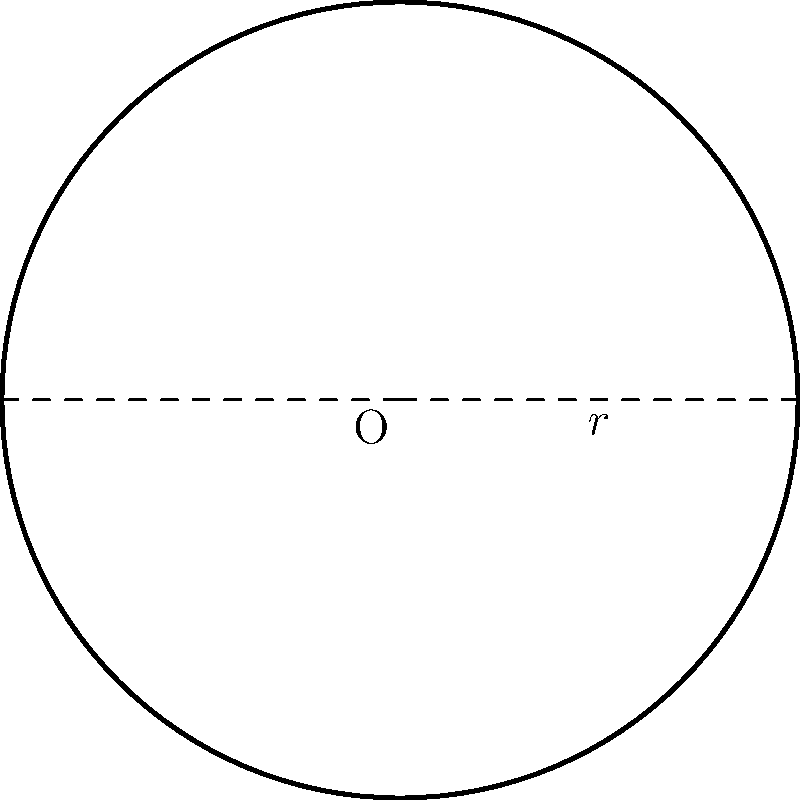A new high-performance motorcycle brake disc is being designed with a radius of 15 cm. What is the total surface area of the brake disc, rounded to the nearest square centimeter? To find the area of the circular brake disc, we can use the formula for the area of a circle:

$$A = \pi r^2$$

Where:
$A$ is the area of the circle
$\pi$ is approximately 3.14159
$r$ is the radius of the circle

Given:
$r = 15$ cm

Step 1: Substitute the value of $r$ into the formula:
$$A = \pi (15\text{ cm})^2$$

Step 2: Calculate the square of the radius:
$$A = \pi (225\text{ cm}^2)$$

Step 3: Multiply by $\pi$:
$$A \approx 3.14159 \times 225\text{ cm}^2 = 706.86\text{ cm}^2$$

Step 4: Round to the nearest square centimeter:
$$A \approx 707\text{ cm}^2$$

Therefore, the total surface area of the brake disc is approximately 707 square centimeters.
Answer: 707 cm² 